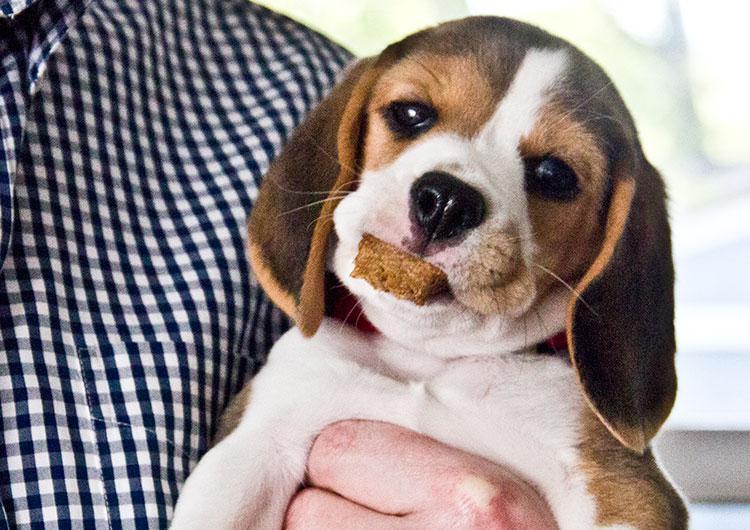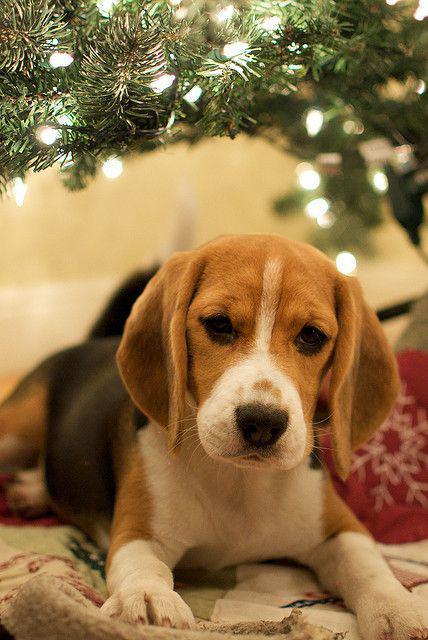The first image is the image on the left, the second image is the image on the right. Considering the images on both sides, is "An image shows a person's hand around at least one beagle dog." valid? Answer yes or no. Yes. The first image is the image on the left, the second image is the image on the right. Analyze the images presented: Is the assertion "A single dog is lying down relaxing in the image on the right." valid? Answer yes or no. Yes. 